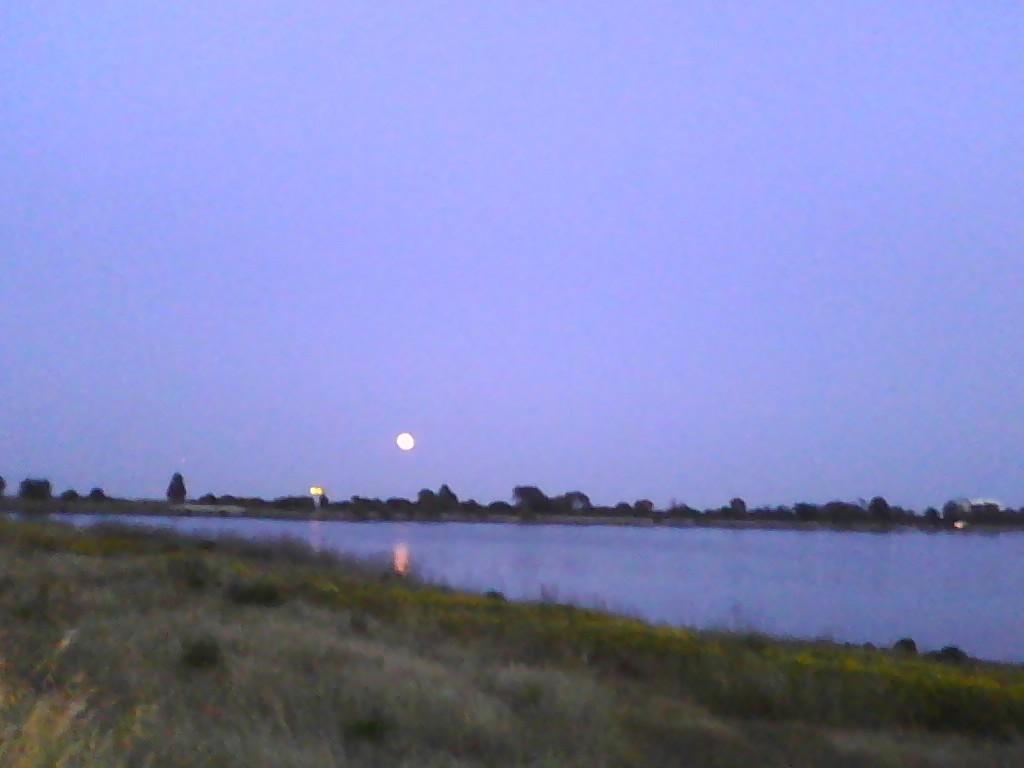What is visible in the image that is not solid? Water is visible in the image and is not solid. What type of vegetation can be seen in the image? There are trees in the image, and they are described as green in color. What celestial body is present in the image? The moon is present in the image, and it is described as white in color. What is the color of the sky in the image? The sky is visible in the image, and it is described as blue in color. What type of hammer is being used to measure the weight of the trees in the image? There is no hammer or scale present in the image, and therefore no such activity can be observed. 